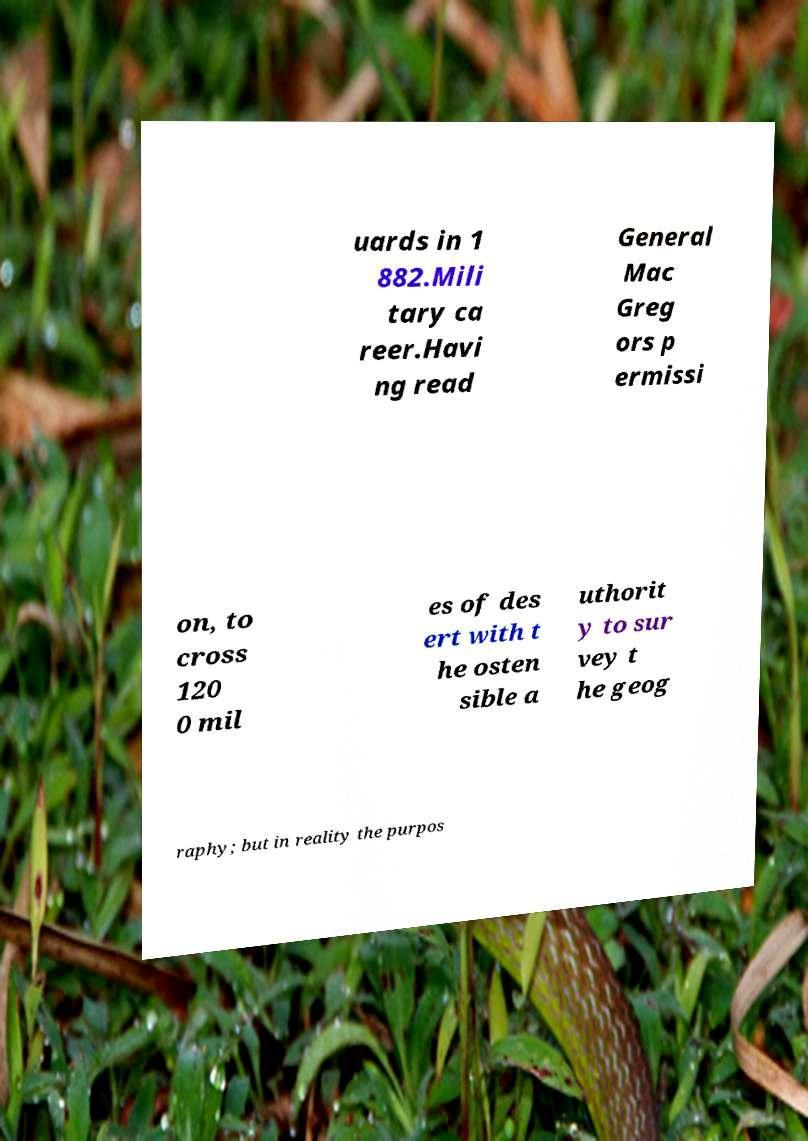Can you accurately transcribe the text from the provided image for me? uards in 1 882.Mili tary ca reer.Havi ng read General Mac Greg ors p ermissi on, to cross 120 0 mil es of des ert with t he osten sible a uthorit y to sur vey t he geog raphy; but in reality the purpos 